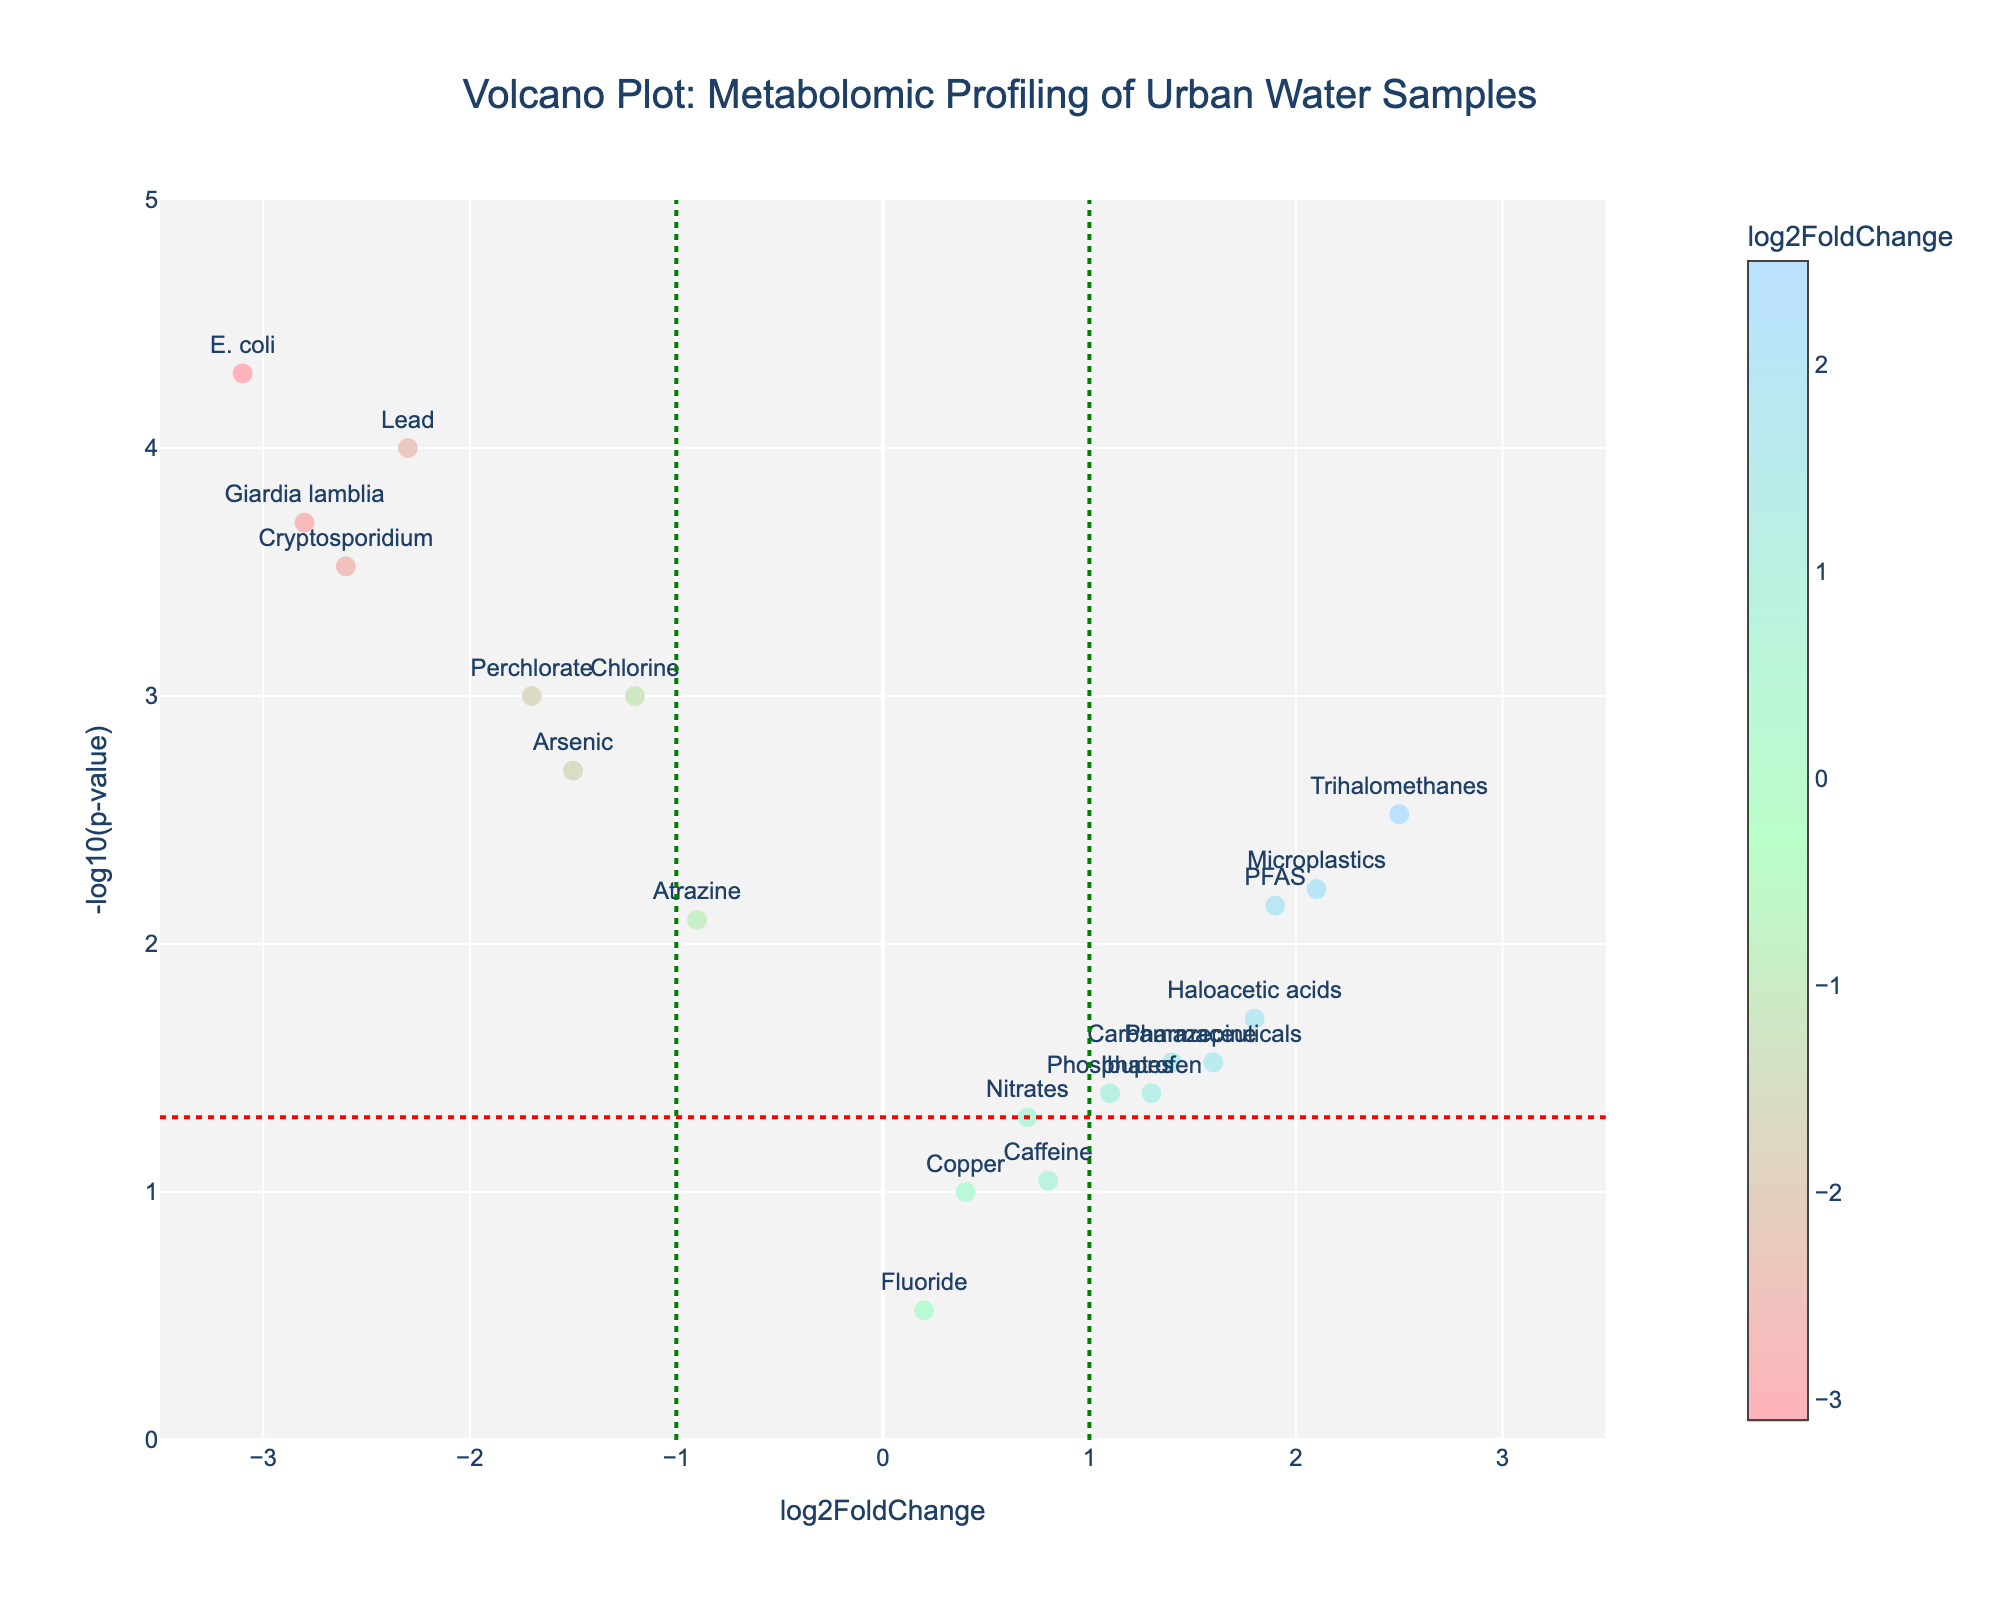What's the title of the plot? The title of the plot is usually displayed at the top of the figure in larger and bold text. In this case, the title above the volcano plot reads "Volcano Plot: Metabolomic Profiling of Urban Water Samples".
Answer: Volcano Plot: Metabolomic Profiling of Urban Water Samples What do the x-axis and y-axis represent? The x-axis is labeled "log2FoldChange" and the y-axis is labeled "-log10(p-value)", indicating that the x-axis represents the log base 2 fold change in metabolite concentration, and the y-axis represents the negative log base 10 of the p-value for each metabolite.
Answer: log2FoldChange and -log10(p-value) How many vertical and horizontal cutoff lines are there? The plot features three vertical lines and one horizontal line, which serve as cutoffs. The vertical lines are drawn at x = -1 and x = 1 (green dashed), representing positive and negative log2 fold change cutoffs, and the horizontal line is drawn at y = -log10(0.05) (red dashed), representing the p-value cutoff.
Answer: Four Which metabolite has the highest -log10(p-value)? To find the metabolite with the highest -log10(p-value), we look at the top-most point in the plot. The hover information reveals this to be E. coli.
Answer: E. coli How many metabolites have a log2FoldChange greater than 0 and a -log10(p-value) greater than 1.3? Several metabolites are located in the region where log2FoldChange > 0 and -log10(p-value) > 1.3. By counting the points in that area, we see the metabolites Trihalomethanes, Haloacetic acids, Phosphates, PFAS, Microplastics, Pharmaceuticals, Ibuprofen, and Carbamazepine fall in this range.
Answer: 8 Compare the log2FoldChange of Chlorine and Arsenic. Which one is lower? Chlorine has a log2FoldChange of -1.2, and Arsenic has a log2FoldChange of -1.5. Comparing these, Arsenic has the lower log2FoldChange.
Answer: Arsenic Which metabolites are affected negatively in urban water samples (log2FoldChange < -1) and are statistically significant (-log10(p-value) > 1.3)? To find negatively affected metabolites that are statistically significant, look for points in the lower left quadrant and above the horizontal cutoff. These include Lead, E. coli, Giardia lamblia, Cryptosporidium, Perchlorate, and Arsenic.
Answer: Lead, E. coli, Giardia lamblia, Cryptosporidium, Perchlorate, Arsenic Which metabolite has the lowest p-value? To determine the metabolite with the lowest p-value, we identify the point with the highest value on the y-axis (-log10(p-value)). The hover information tells us that E. coli has the highest -log10(p-value).
Answer: E. coli What is the log2FoldChange and p-value for Microplastics? Hovering over the point representing Microplastics in the plot shows the log2FoldChange and p-value. These values are given as log2FoldChange: 2.1 and p-value: 0.006.
Answer: log2FoldChange: 2.1, p-value: 0.006 